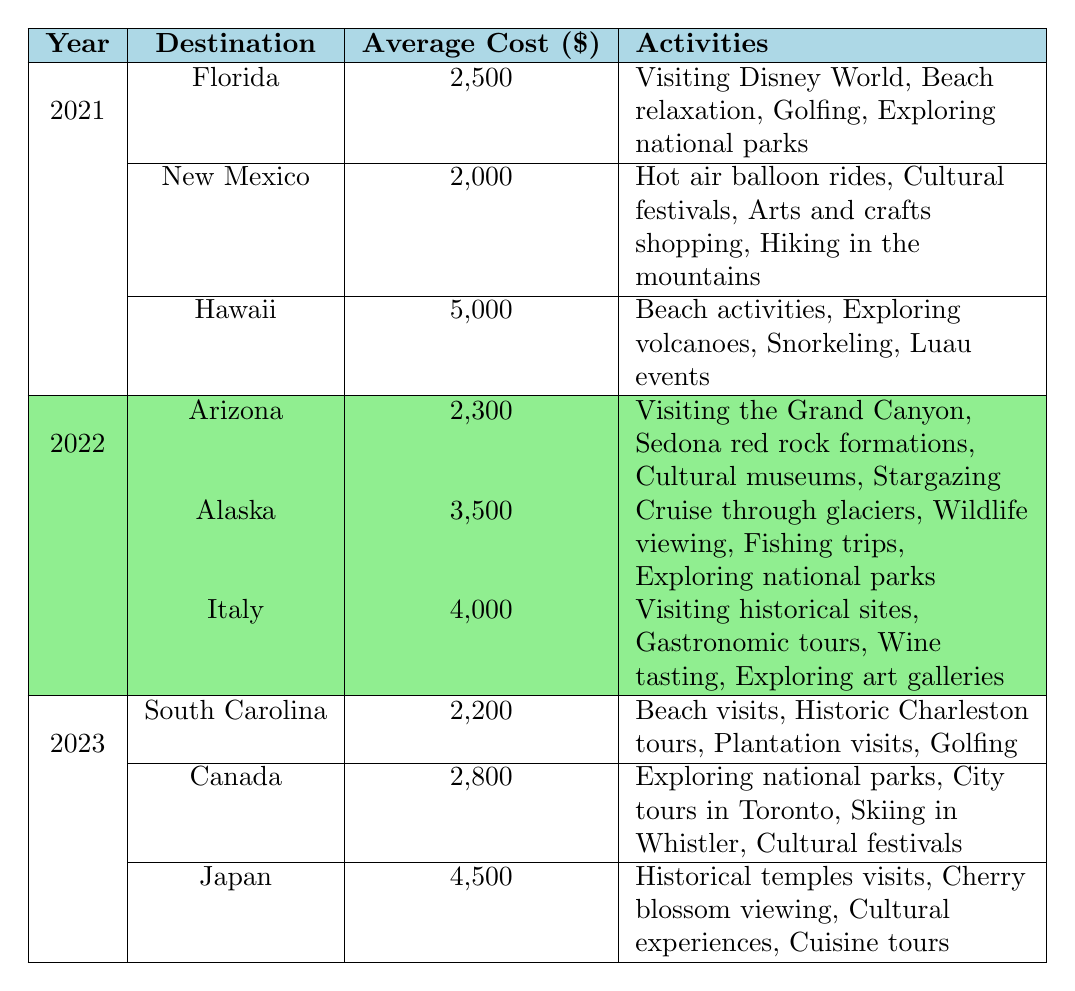What was the average cost of traveling to Hawaii in 2021? The table shows that the average cost for Hawaii in 2021 is 5,000 dollars.
Answer: 5,000 dollars Which destination in 2022 had the highest average cost? Looking at the average costs for 2022, Italy has the highest average cost at 4,000 dollars, while Alaska is next at 3,500 dollars.
Answer: Italy How much cheaper was traveling to South Carolina compared to traveling to Alaska in 2022? The average cost for South Carolina in 2023 is 2,200 dollars, and for Alaska in 2022 it is 3,500 dollars. The difference is 3,500 - 2,200 = 1,300 dollars.
Answer: 1,300 dollars Did any destination in 2023 have an average cost that was less than 3,000 dollars? Yes, South Carolina (2,200 dollars) and Canada (2,800 dollars) both had average costs under 3,000 dollars.
Answer: Yes In which year was the average cost for Arizona lower than that of Florida? The average cost of Arizona in 2022 is 2,300 dollars, while Florida's cost in 2021 is 2,500 dollars. Thus, Arizona is lower.
Answer: 2022 What is the total average cost for all the destinations listed in 2023? The average costs for the destinations in 2023 are 2,200 (South Carolina) + 2,800 (Canada) + 4,500 (Japan) = 9,500 dollars.
Answer: 9,500 dollars Which activities are common between the destinations of Florida and South Carolina? The common activity between Florida and South Carolina is golfing, as both lists include it.
Answer: Golfing If we consider all three years, which destination had the lowest average cost? The lowest average cost across all years is for New Mexico in 2021 at 2,000 dollars, compared to others in the table.
Answer: New Mexico Count how many different activities can be done in Hawaii and Italy combined. Hawaii offers 4 activities and Italy offers 4 activities, so combined there are 4 + 4 = 8 activities.
Answer: 8 activities Was the average cost of traveling to Alaska more than the average cost of traveling to Japan? The average cost for Alaska in 2022 is 3,500 dollars, whereas Japan in 2023 has an average cost of 4,500 dollars. Since 3,500 is less than 4,500, the answer is No.
Answer: No 